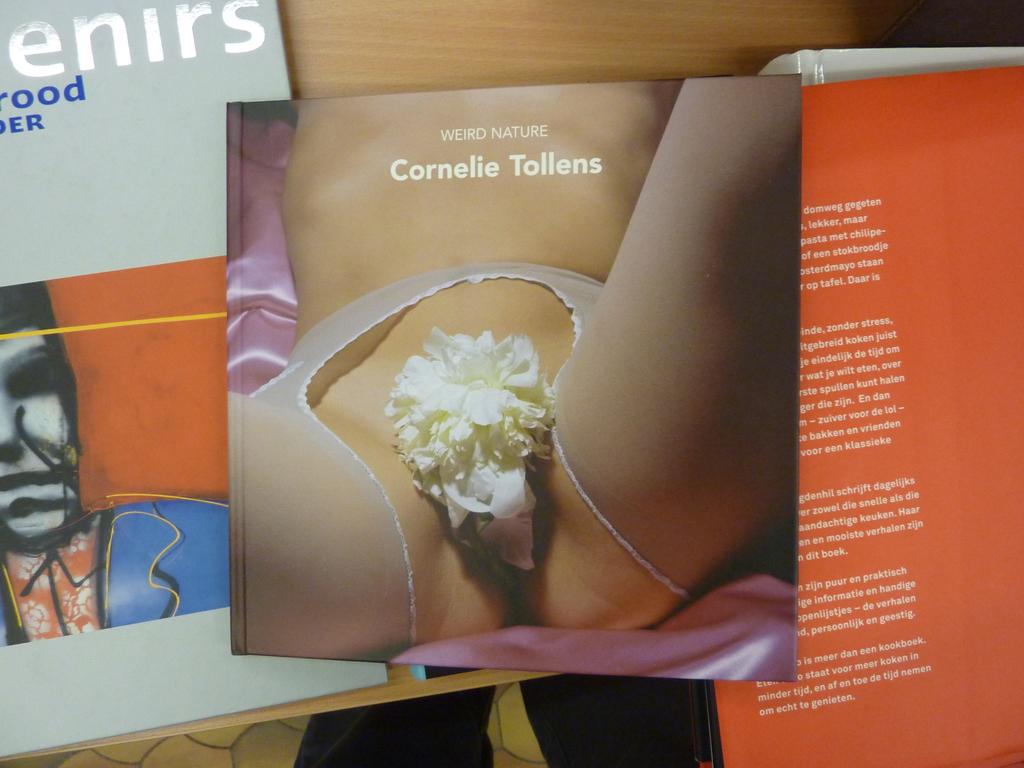Who wrote the book?
Keep it short and to the point. Cornelie tollens. What's the name of the book?
Ensure brevity in your answer.  Weird nature. 